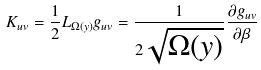Convert formula to latex. <formula><loc_0><loc_0><loc_500><loc_500>K _ { u v } = \frac { 1 } { 2 } L _ { \Omega ( y ) } g _ { u v } = \frac { 1 } { 2 \sqrt { \Omega ( y ) } } \frac { \partial g _ { u v } } { \partial \beta }</formula> 